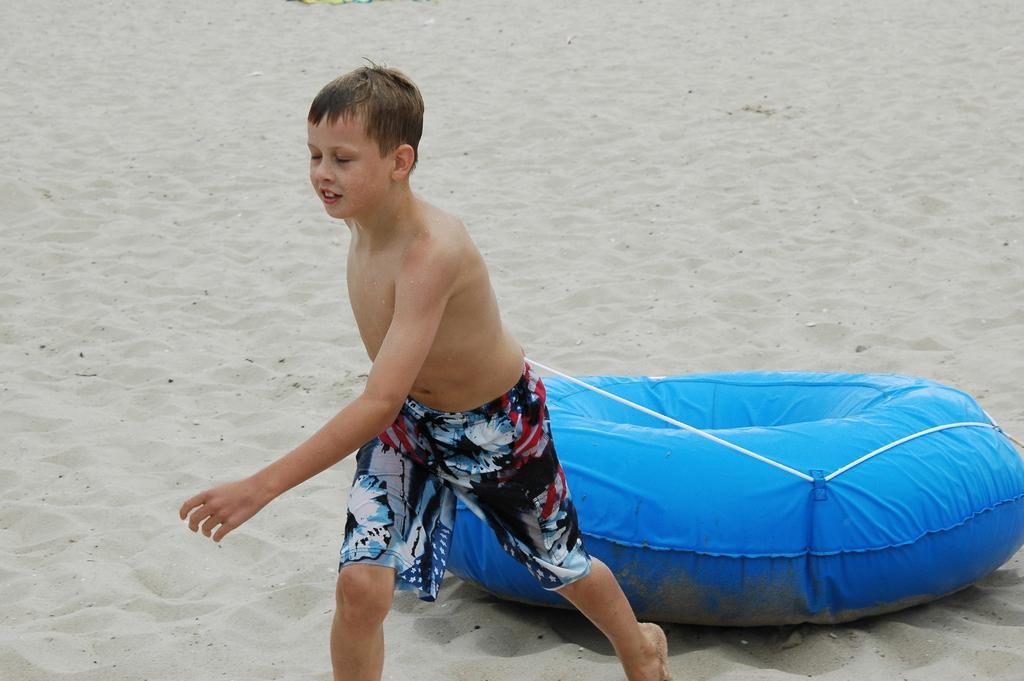Who is present in the image? There is a boy in the image. What is the boy holding in the image? The boy is holding a blue object. What can be seen on the ground in the background of the image? There is sand on the ground in the background of the image. What type of lace can be seen on the boy's clothing in the image? There is no lace visible on the boy's clothing in the image. 